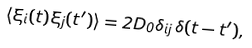Convert formula to latex. <formula><loc_0><loc_0><loc_500><loc_500>\langle \xi _ { i } ( t ) \xi _ { j } ( t ^ { \prime } ) \rangle = 2 D _ { 0 } \delta _ { i j } \, \delta ( t - t ^ { \prime } ) ,</formula> 